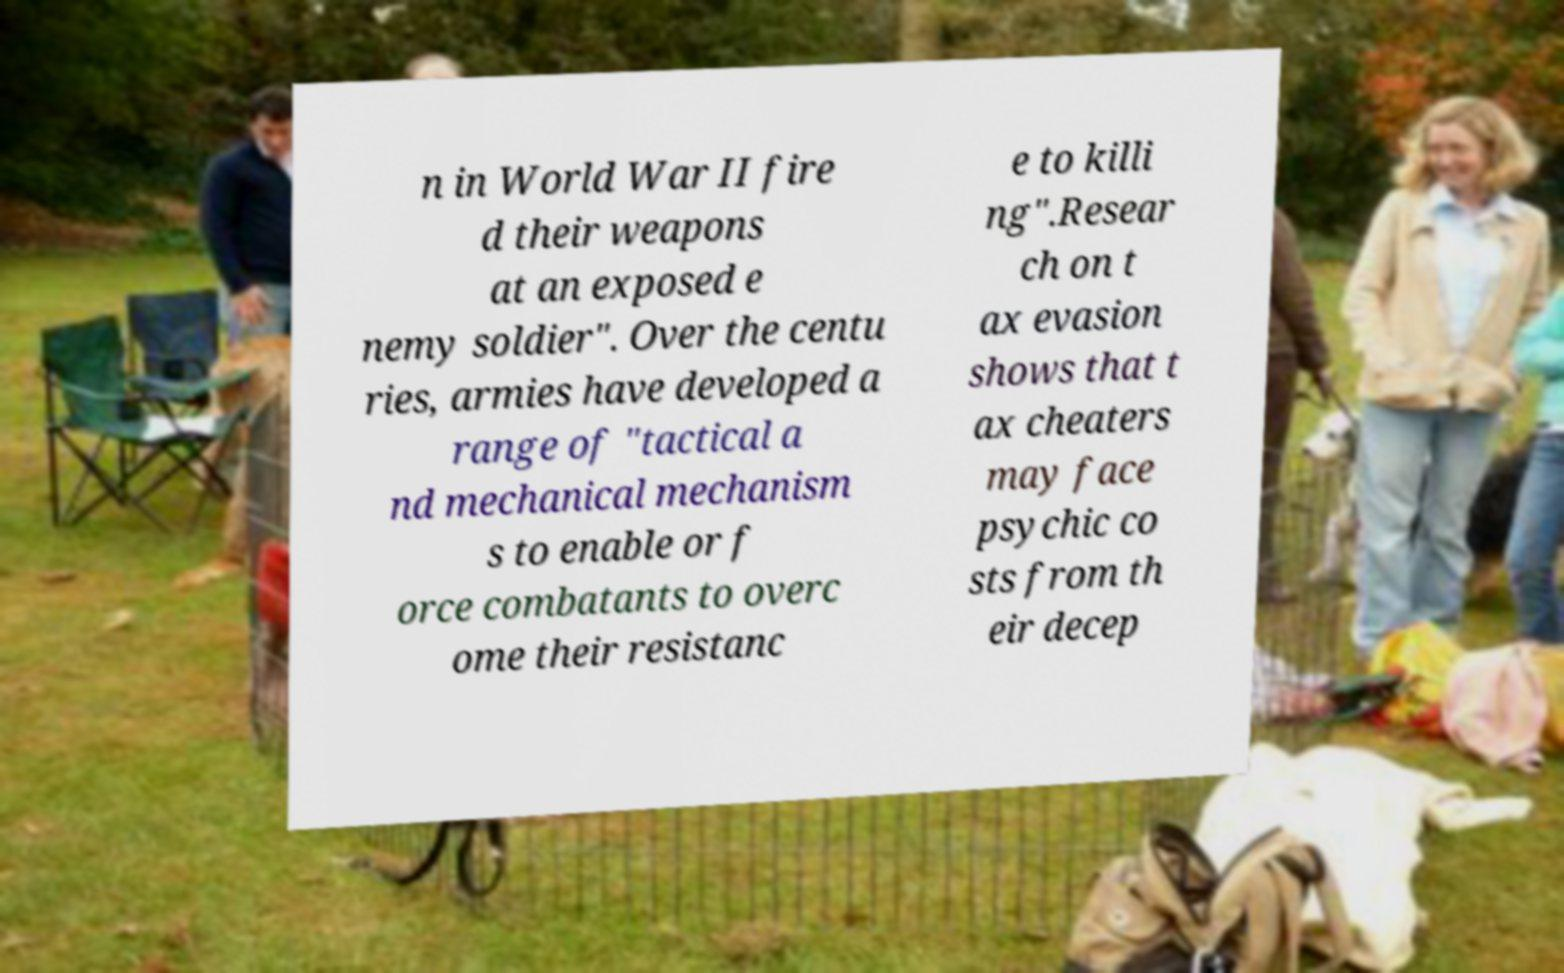Please read and relay the text visible in this image. What does it say? n in World War II fire d their weapons at an exposed e nemy soldier". Over the centu ries, armies have developed a range of "tactical a nd mechanical mechanism s to enable or f orce combatants to overc ome their resistanc e to killi ng".Resear ch on t ax evasion shows that t ax cheaters may face psychic co sts from th eir decep 